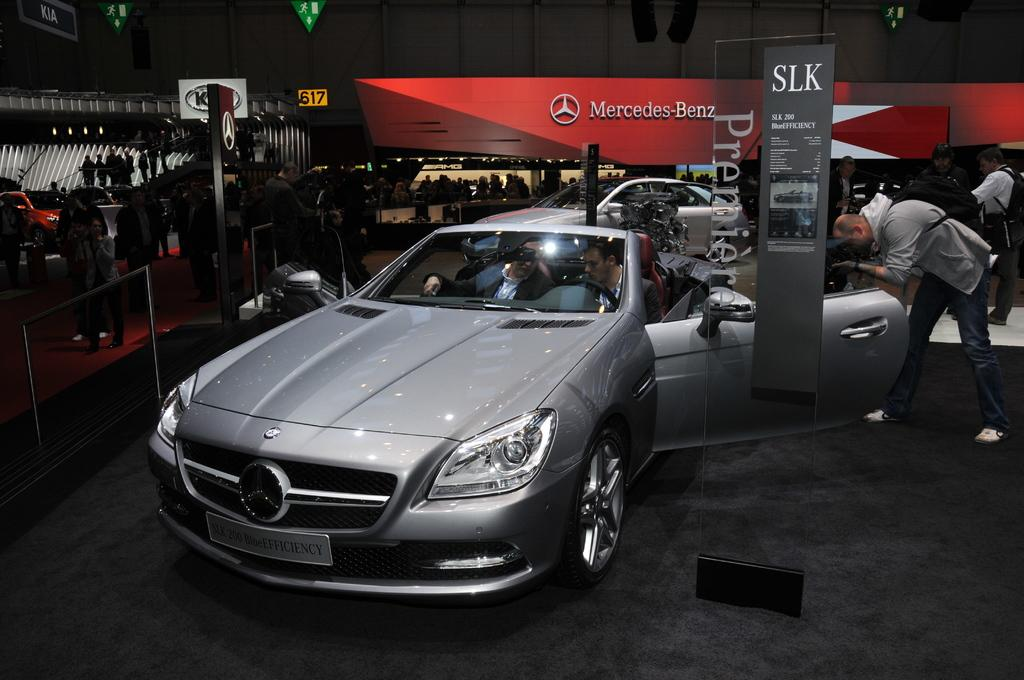What type of vehicles can be seen in the image? There are cars in the image. Are there any individuals present in the image? Yes, there are people in the image. What else can be seen in the image besides cars and people? There are boards in the image. What type of lamp is being used by the people in the image? There is no lamp present in the image; it only features cars, people, and boards. 